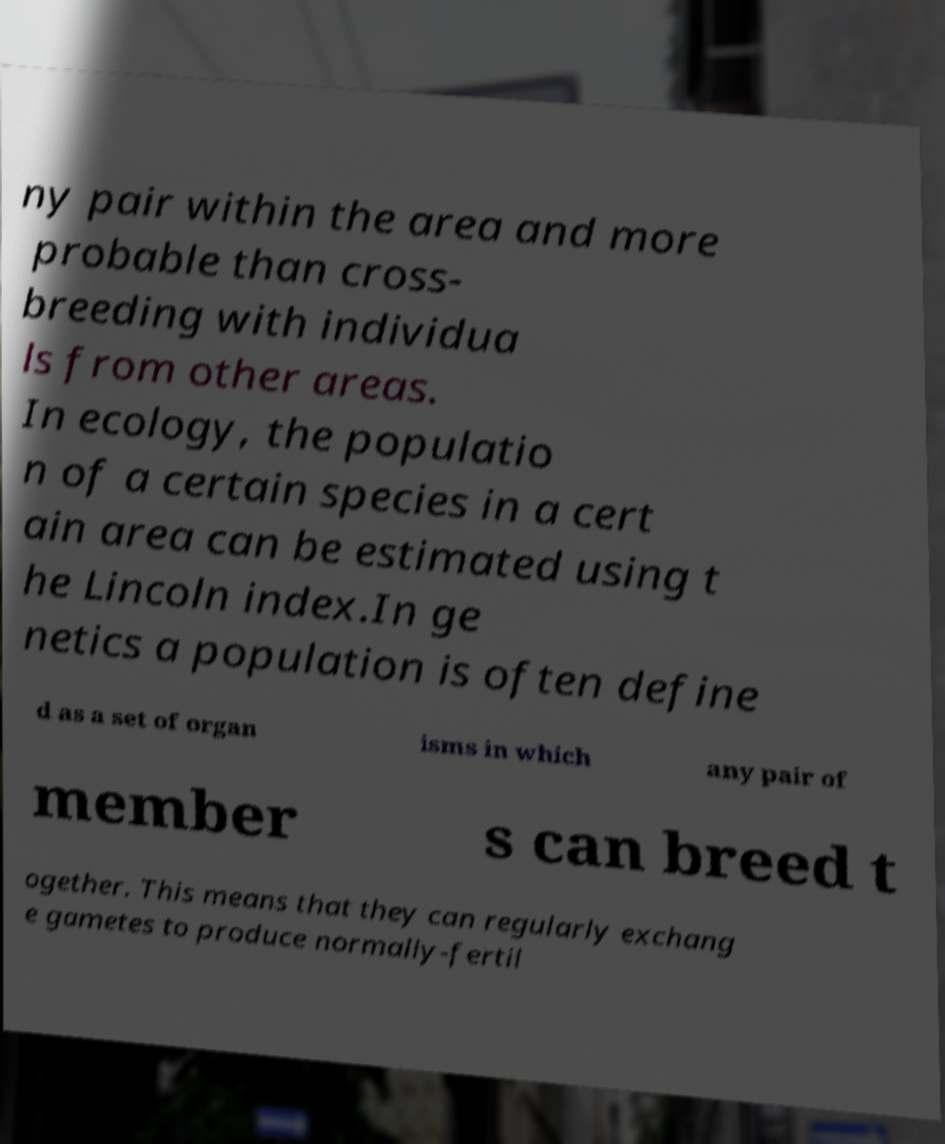Could you extract and type out the text from this image? ny pair within the area and more probable than cross- breeding with individua ls from other areas. In ecology, the populatio n of a certain species in a cert ain area can be estimated using t he Lincoln index.In ge netics a population is often define d as a set of organ isms in which any pair of member s can breed t ogether. This means that they can regularly exchang e gametes to produce normally-fertil 